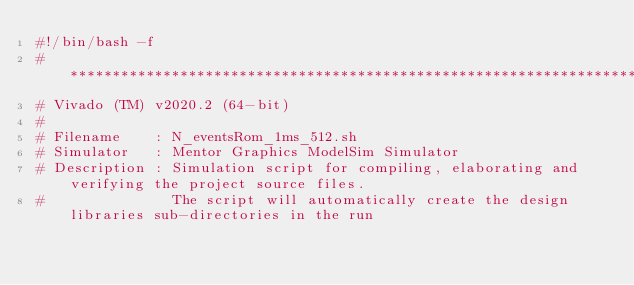<code> <loc_0><loc_0><loc_500><loc_500><_Bash_>#!/bin/bash -f
#*********************************************************************************************************
# Vivado (TM) v2020.2 (64-bit)
#
# Filename    : N_eventsRom_1ms_512.sh
# Simulator   : Mentor Graphics ModelSim Simulator
# Description : Simulation script for compiling, elaborating and verifying the project source files.
#               The script will automatically create the design libraries sub-directories in the run</code> 